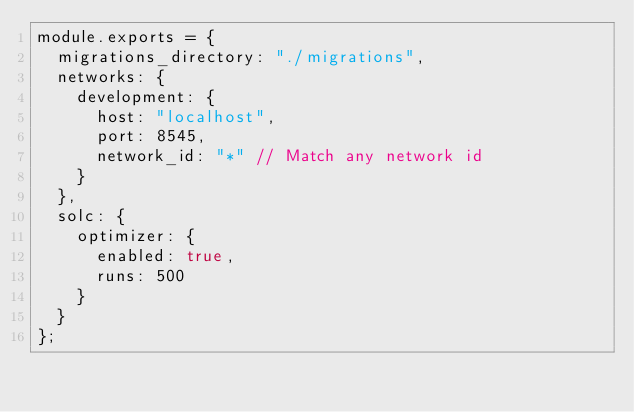Convert code to text. <code><loc_0><loc_0><loc_500><loc_500><_JavaScript_>module.exports = {
  migrations_directory: "./migrations",
  networks: {
    development: {
      host: "localhost",
      port: 8545,
      network_id: "*" // Match any network id
    }
  },
  solc: {
    optimizer: {
      enabled: true,
      runs: 500
    }
  } 
};
</code> 